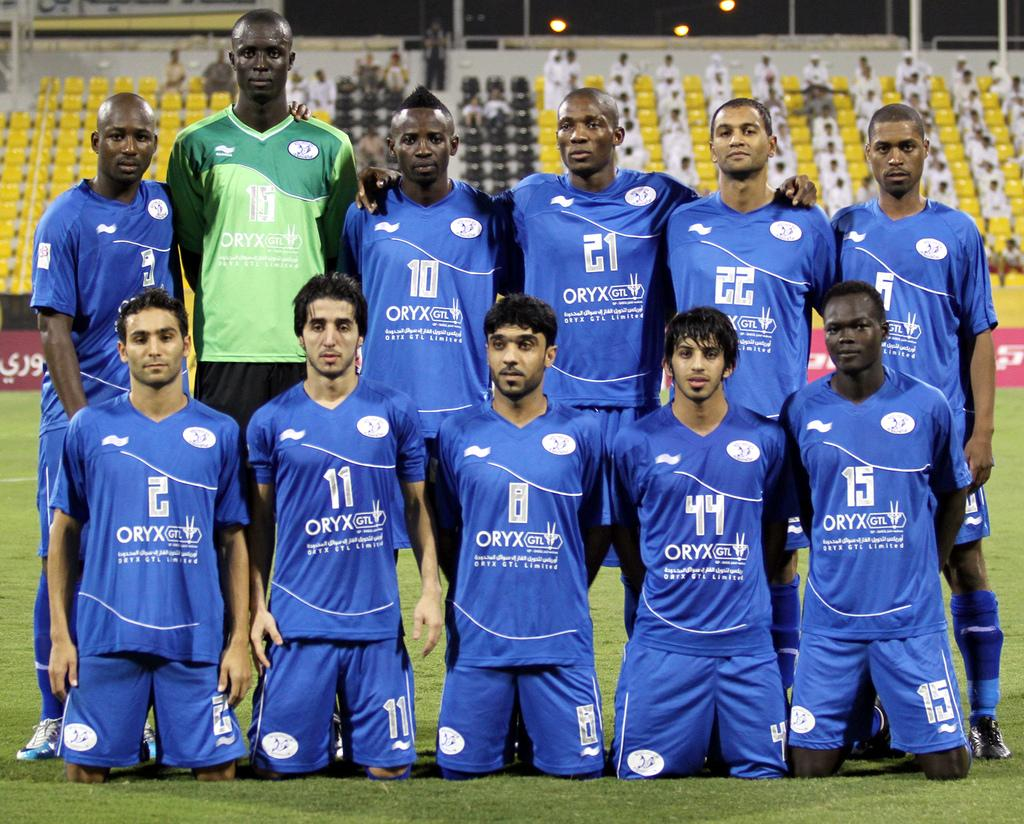<image>
Present a compact description of the photo's key features. A sport team with ORYX on their jerseys are lined up for a photo, all but one in matching blue uniforms. 